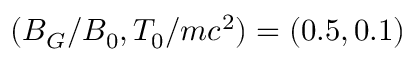Convert formula to latex. <formula><loc_0><loc_0><loc_500><loc_500>( B _ { G } / B _ { 0 } , T _ { 0 } / m c ^ { 2 } ) = ( 0 . 5 , 0 . 1 )</formula> 